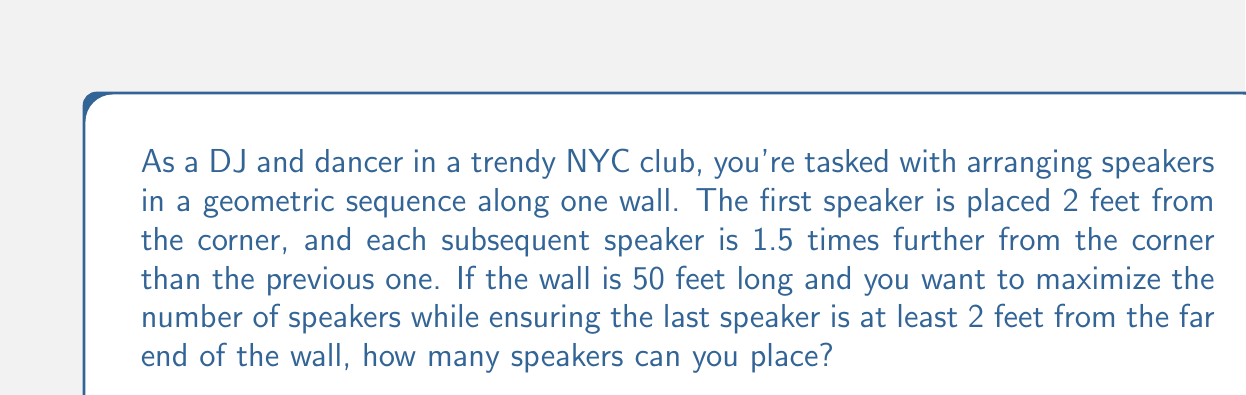Show me your answer to this math problem. Let's approach this step-by-step:

1) We're dealing with a geometric sequence where:
   - First term, $a = 2$ (feet)
   - Common ratio, $r = 1.5$

2) The general term of a geometric sequence is given by:
   $$a_n = ar^{n-1}$$
   where $n$ is the position of the term.

3) We need to find the largest $n$ such that:
   $$ar^{n-1} + 2 \leq 50$$
   (The +2 accounts for the 2 feet buffer at the end)

4) Substituting our values:
   $$2(1.5)^{n-1} + 2 \leq 50$$

5) Solving for $n$:
   $$2(1.5)^{n-1} \leq 48$$
   $$(1.5)^{n-1} \leq 24$$
   $$n-1 \leq \log_{1.5}24$$
   $$n \leq \log_{1.5}24 + 1$$

6) Using a calculator or logarithm properties:
   $$n \leq \frac{\ln 24}{\ln 1.5} + 1 \approx 9.03$$

7) Since $n$ must be an integer, the largest value it can take is 9.

8) We can verify:
   $$2(1.5)^{8} + 2 \approx 47.51 < 50$$
   $$2(1.5)^{9} + 2 \approx 69.27 > 50$$

Therefore, we can place 9 speakers along the wall.
Answer: 9 speakers 